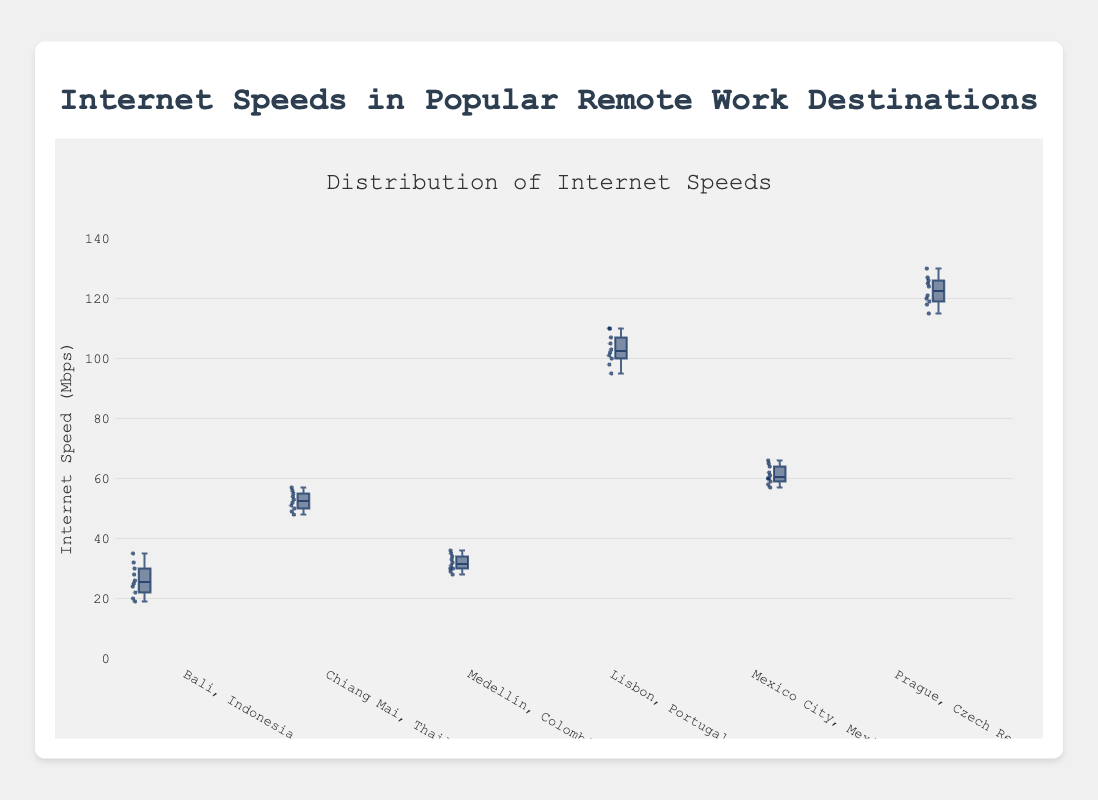Which location has the highest median internet speed? To find the location with the highest median internet speed, identify the middle value of the box in each box plot. Prague, Czech Republic has the highest median.
Answer: Prague, Czech Republic What is the range of internet speeds in Lisbon, Portugal? The range is the difference between the maximum and minimum data points. For Lisbon, Portugal, the maximum is 110 Mbps and the minimum is 95 Mbps. So, the range is 110 - 95 = 15 Mbps.
Answer: 15 Mbps Which location has the smallest interquartile range (IQR)? The IQR is the difference between the upper quartile and the lower quartile (the length of the box). Medellín, Colombia has the smallest IQR.
Answer: Medellín, Colombia How does the median internet speed in Chiang Mai, Thailand compare to Bali, Indonesia? Compare the middle value of the boxes in the plots for Chiang Mai and Bali. The median internet speed in Chiang Mai (around 52 Mbps) is higher than in Bali (around 25 Mbps).
Answer: Chiang Mai is higher What is the median internet speed in Mexico City, Mexico? The median is the value at the middle of the box in Mexico City’s box plot. For Mexico City, it's around 60 Mbps.
Answer: 60 Mbps Which location has the most outliers? Outliers are shown as individual points outside the whiskers. Bali, Indonesia has the most outliers (one).
Answer: Bali, Indonesia Which two locations have the closest range of internet speeds? Compare the ranges (difference between the max and min data points) of each location. Medellín, Colombia and Mexico City, Mexico have similar ranges (8 and 9 Mbps, respectively).
Answer: Medellín, Colombia and Mexico City, Mexico Which location has the highest maximum internet speed? Look at the top whisker or top outlier point for each box plot. Prague, Czech Republic has the highest maximum internet speed (130 Mbps).
Answer: Prague, Czech Republic Which location has a more consistent internet speed, Chiang Mai or Bali? Consistency can be measured by the spread of the data points. Chiang Mai has less spread with a tighter range of internet speeds compared to Bali.
Answer: Chiang Mai What is the approximate median value for Lisbon, Portugal? The median is the center line within the box for Lisbon, Portugal, which is around 102 Mbps.
Answer: 102 Mbps 